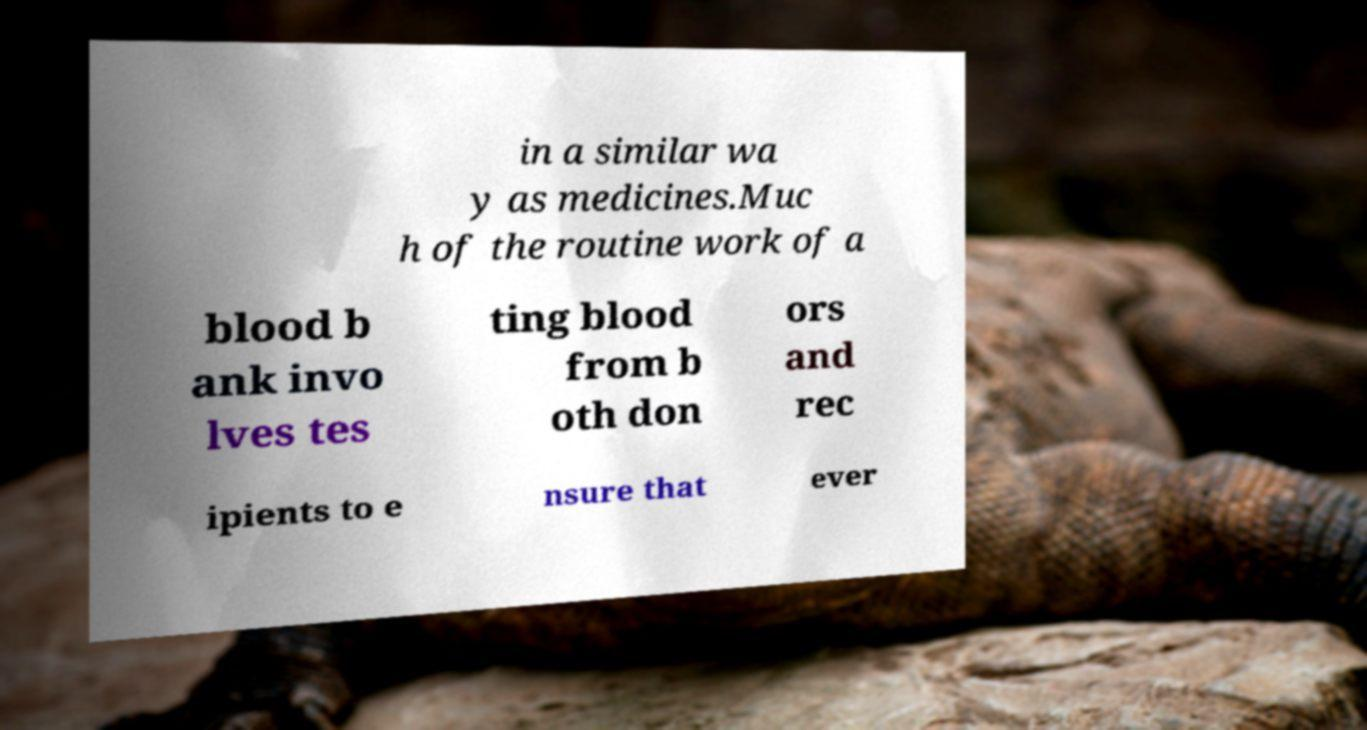Please identify and transcribe the text found in this image. in a similar wa y as medicines.Muc h of the routine work of a blood b ank invo lves tes ting blood from b oth don ors and rec ipients to e nsure that ever 